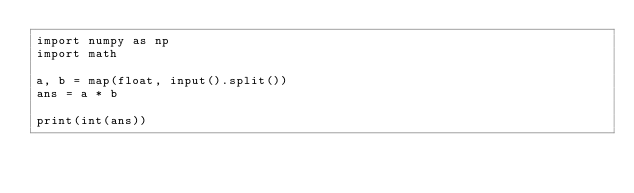<code> <loc_0><loc_0><loc_500><loc_500><_Python_>import numpy as np
import math

a, b = map(float, input().split())
ans = a * b

print(int(ans))
</code> 